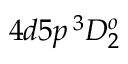<formula> <loc_0><loc_0><loc_500><loc_500>4 d 5 p \, ^ { 3 } D _ { 2 } ^ { o }</formula> 